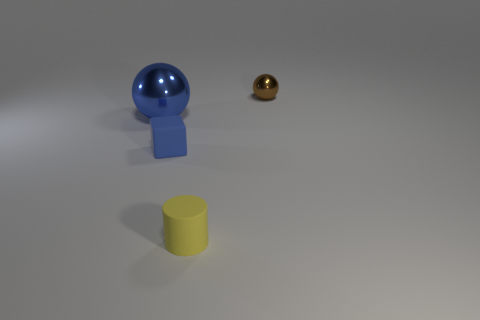Is there anything else that is the same shape as the yellow object?
Keep it short and to the point. No. Is there any other thing that is the same size as the blue metal object?
Your answer should be compact. No. Is the brown shiny sphere the same size as the blue sphere?
Offer a terse response. No. Are there more small yellow matte cylinders than large cyan metallic blocks?
Provide a succinct answer. Yes. What number of other objects are the same color as the big ball?
Make the answer very short. 1. What number of objects are tiny brown balls or tiny yellow matte cylinders?
Provide a short and direct response. 2. There is a rubber object that is in front of the tiny cube; is it the same shape as the large metal thing?
Offer a very short reply. No. What is the color of the ball that is to the right of the matte object that is behind the yellow rubber thing?
Provide a short and direct response. Brown. Is the number of big brown metal objects less than the number of tiny yellow rubber cylinders?
Offer a terse response. Yes. Are there any tiny gray spheres that have the same material as the brown sphere?
Your answer should be compact. No. 